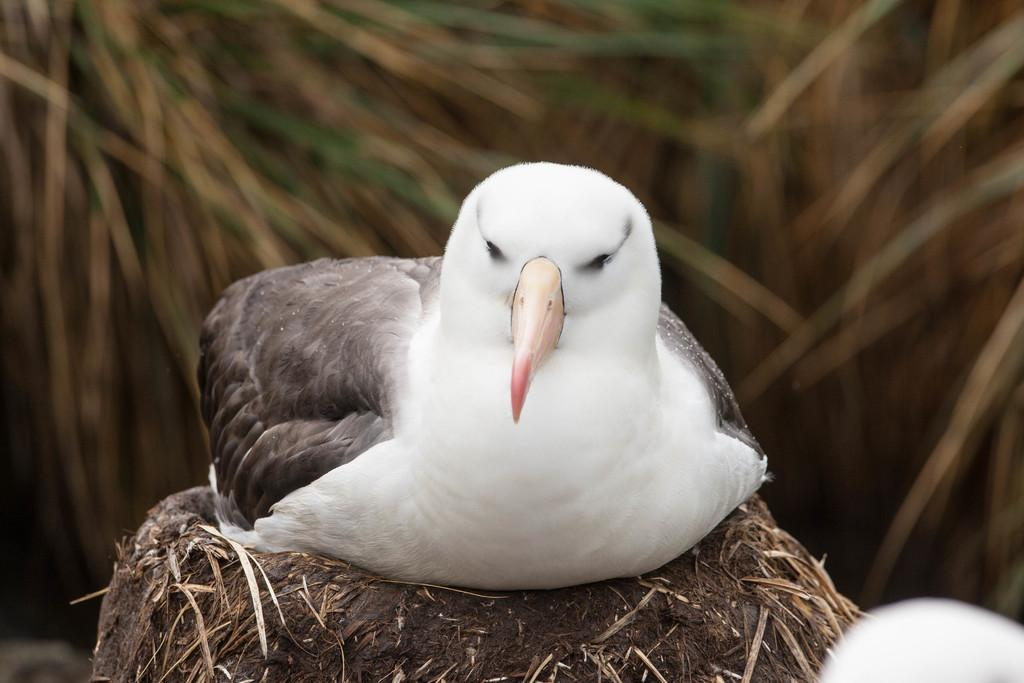What type of animal can be seen in the image? There is a bird in the image. Where is the bird located in the image? The bird is sitting on a nest. Can you describe the background of the image? The background of the image is blurred. What type of feast is being prepared in the garden in the image? There is no feast or garden present in the image; it features a bird sitting on a nest with a blurred background. 